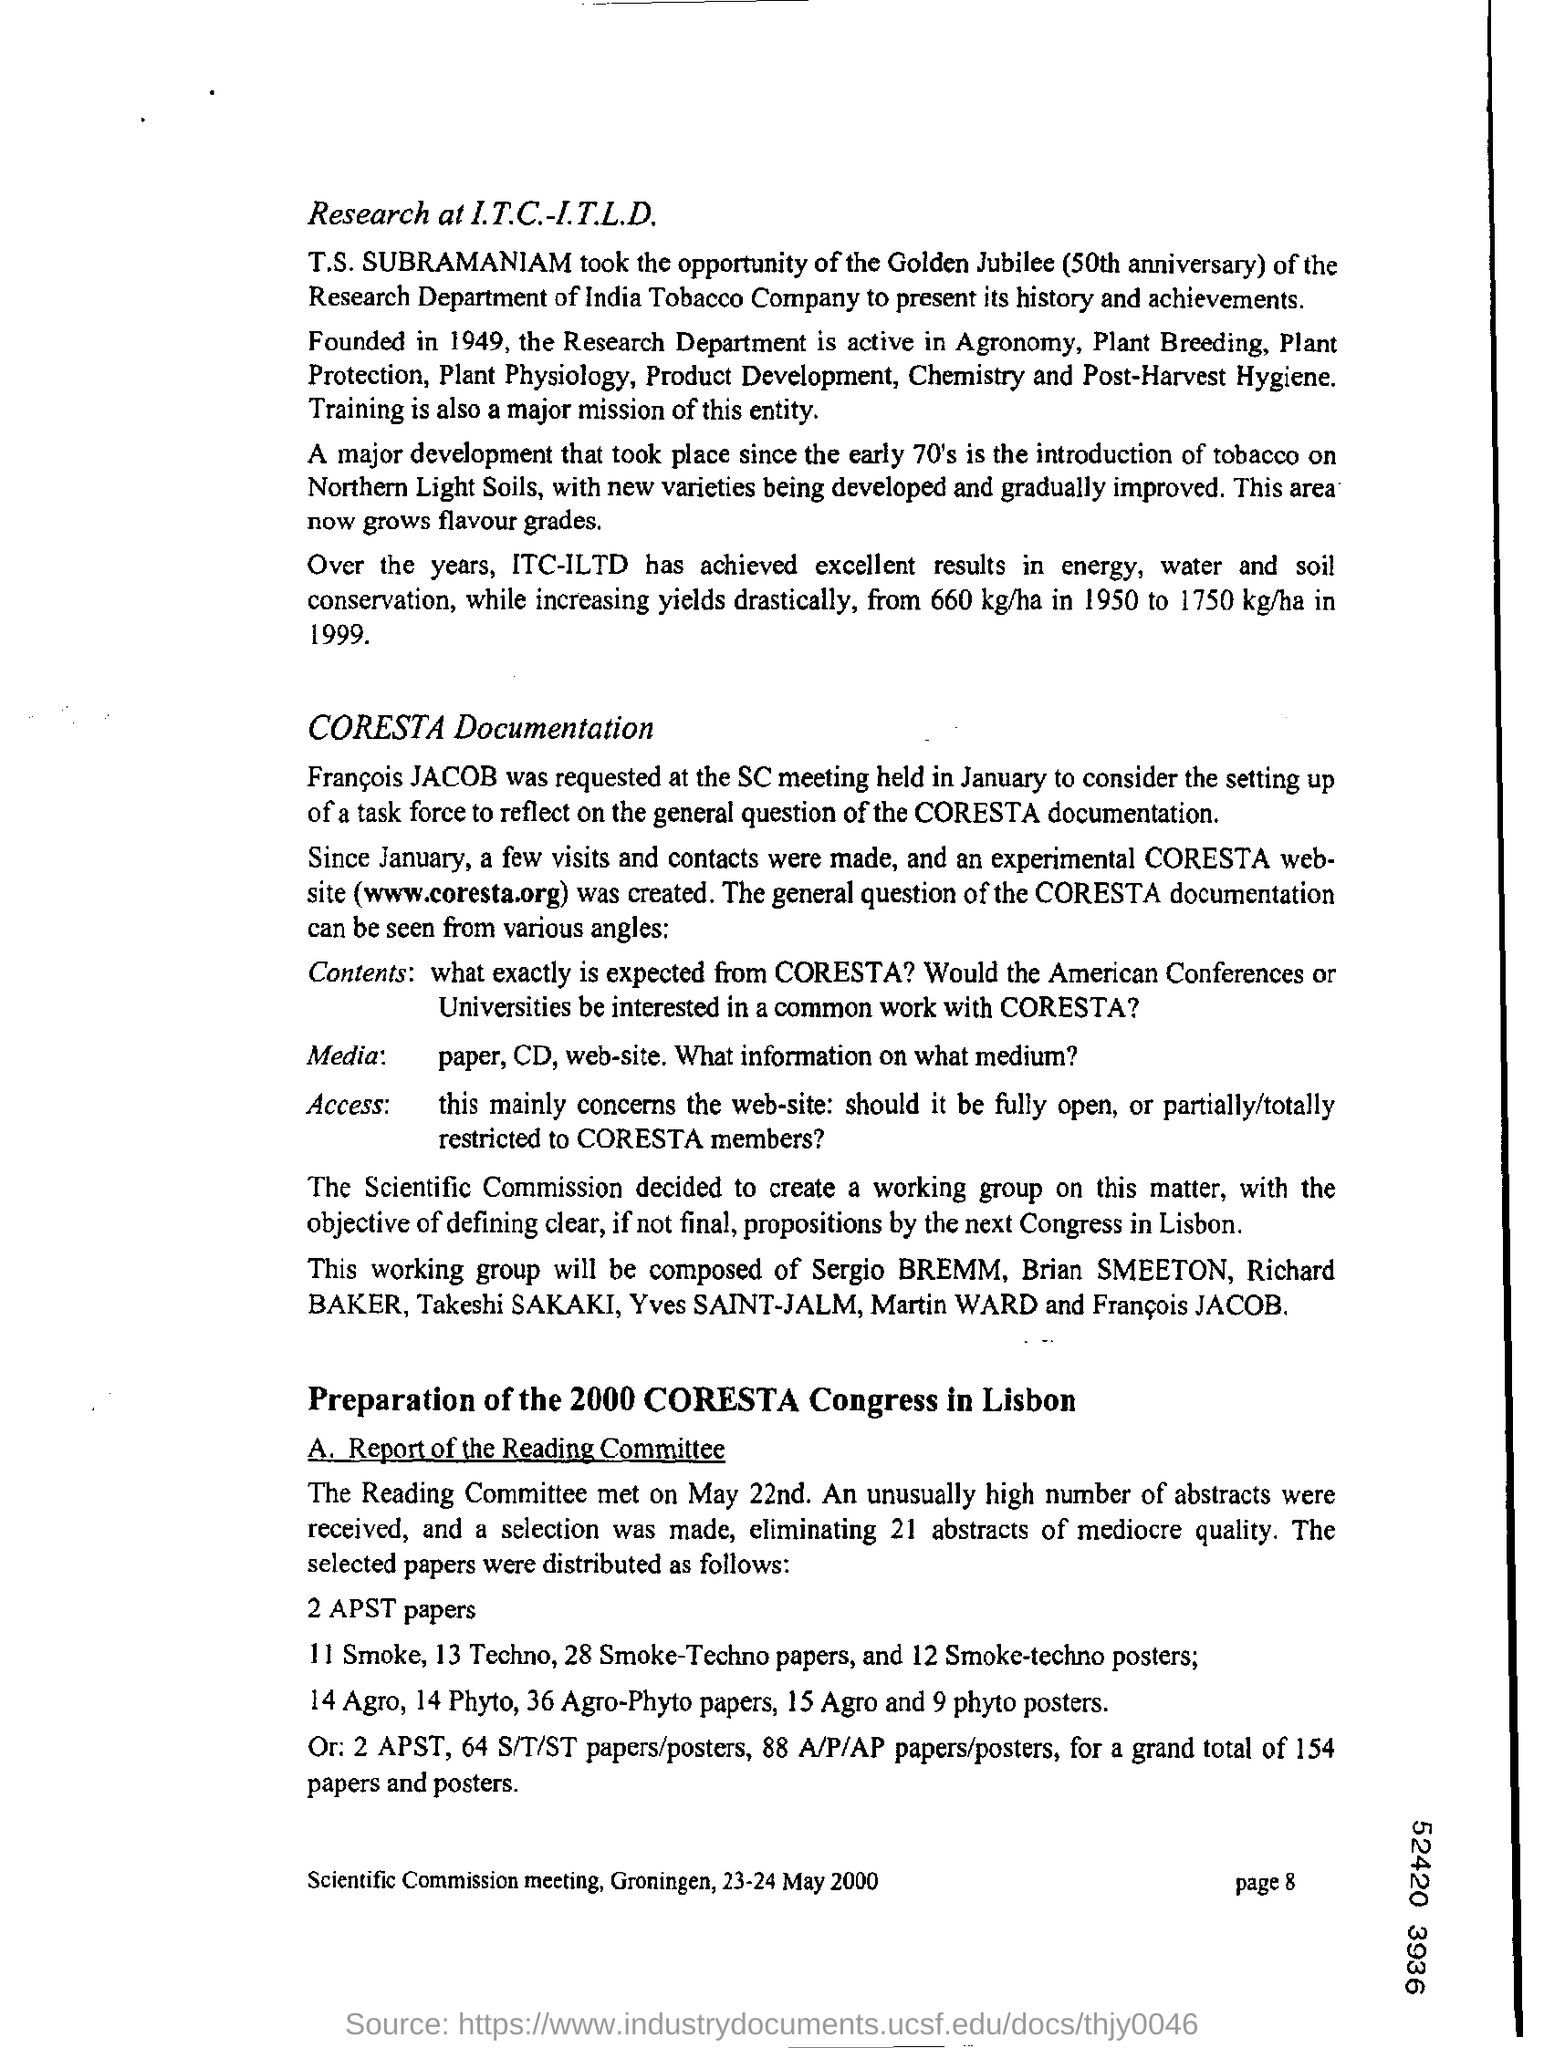When was the research department founded?
Provide a succinct answer. 1949. 